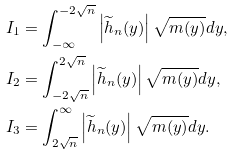Convert formula to latex. <formula><loc_0><loc_0><loc_500><loc_500>& I _ { 1 } = \int _ { - \infty } ^ { - 2 \sqrt { n } } \left | \widetilde { h } _ { n } ( y ) \right | \sqrt { m ( y ) } d y , \\ & I _ { 2 } = \int _ { - 2 \sqrt { n } } ^ { 2 \sqrt { n } } \left | \widetilde { h } _ { n } ( y ) \right | \sqrt { m ( y ) } d y , \\ & I _ { 3 } = \int _ { 2 \sqrt { n } } ^ { \infty } \left | \widetilde { h } _ { n } ( y ) \right | \sqrt { m ( y ) } d y .</formula> 